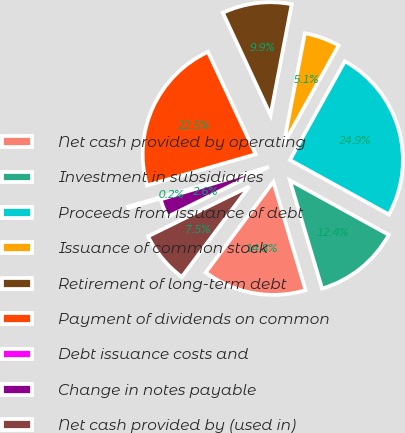<chart> <loc_0><loc_0><loc_500><loc_500><pie_chart><fcel>Net cash provided by operating<fcel>Investment in subsidiaries<fcel>Proceeds from issuance of debt<fcel>Issuance of common stock<fcel>Retirement of long-term debt<fcel>Payment of dividends on common<fcel>Debt issuance costs and<fcel>Change in notes payable<fcel>Net cash provided by (used in)<nl><fcel>14.81%<fcel>12.38%<fcel>24.93%<fcel>5.08%<fcel>9.94%<fcel>22.5%<fcel>0.21%<fcel>2.64%<fcel>7.51%<nl></chart> 